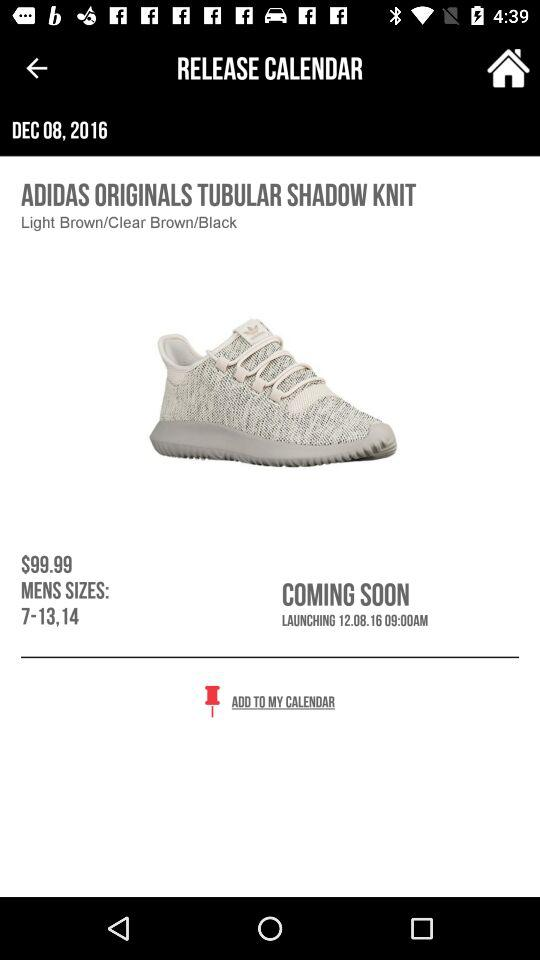What is the launch date of the shoes? The launch date is December 8, 2016. 